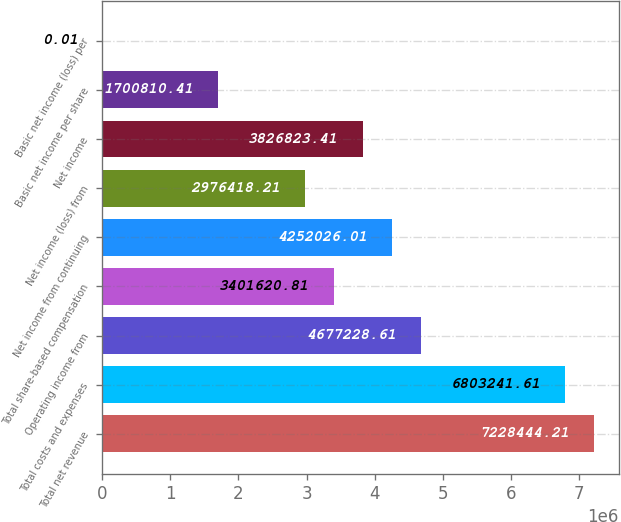Convert chart to OTSL. <chart><loc_0><loc_0><loc_500><loc_500><bar_chart><fcel>Total net revenue<fcel>Total costs and expenses<fcel>Operating income from<fcel>Total share-based compensation<fcel>Net income from continuing<fcel>Net income (loss) from<fcel>Net income<fcel>Basic net income per share<fcel>Basic net income (loss) per<nl><fcel>7.22844e+06<fcel>6.80324e+06<fcel>4.67723e+06<fcel>3.40162e+06<fcel>4.25203e+06<fcel>2.97642e+06<fcel>3.82682e+06<fcel>1.70081e+06<fcel>0.01<nl></chart> 